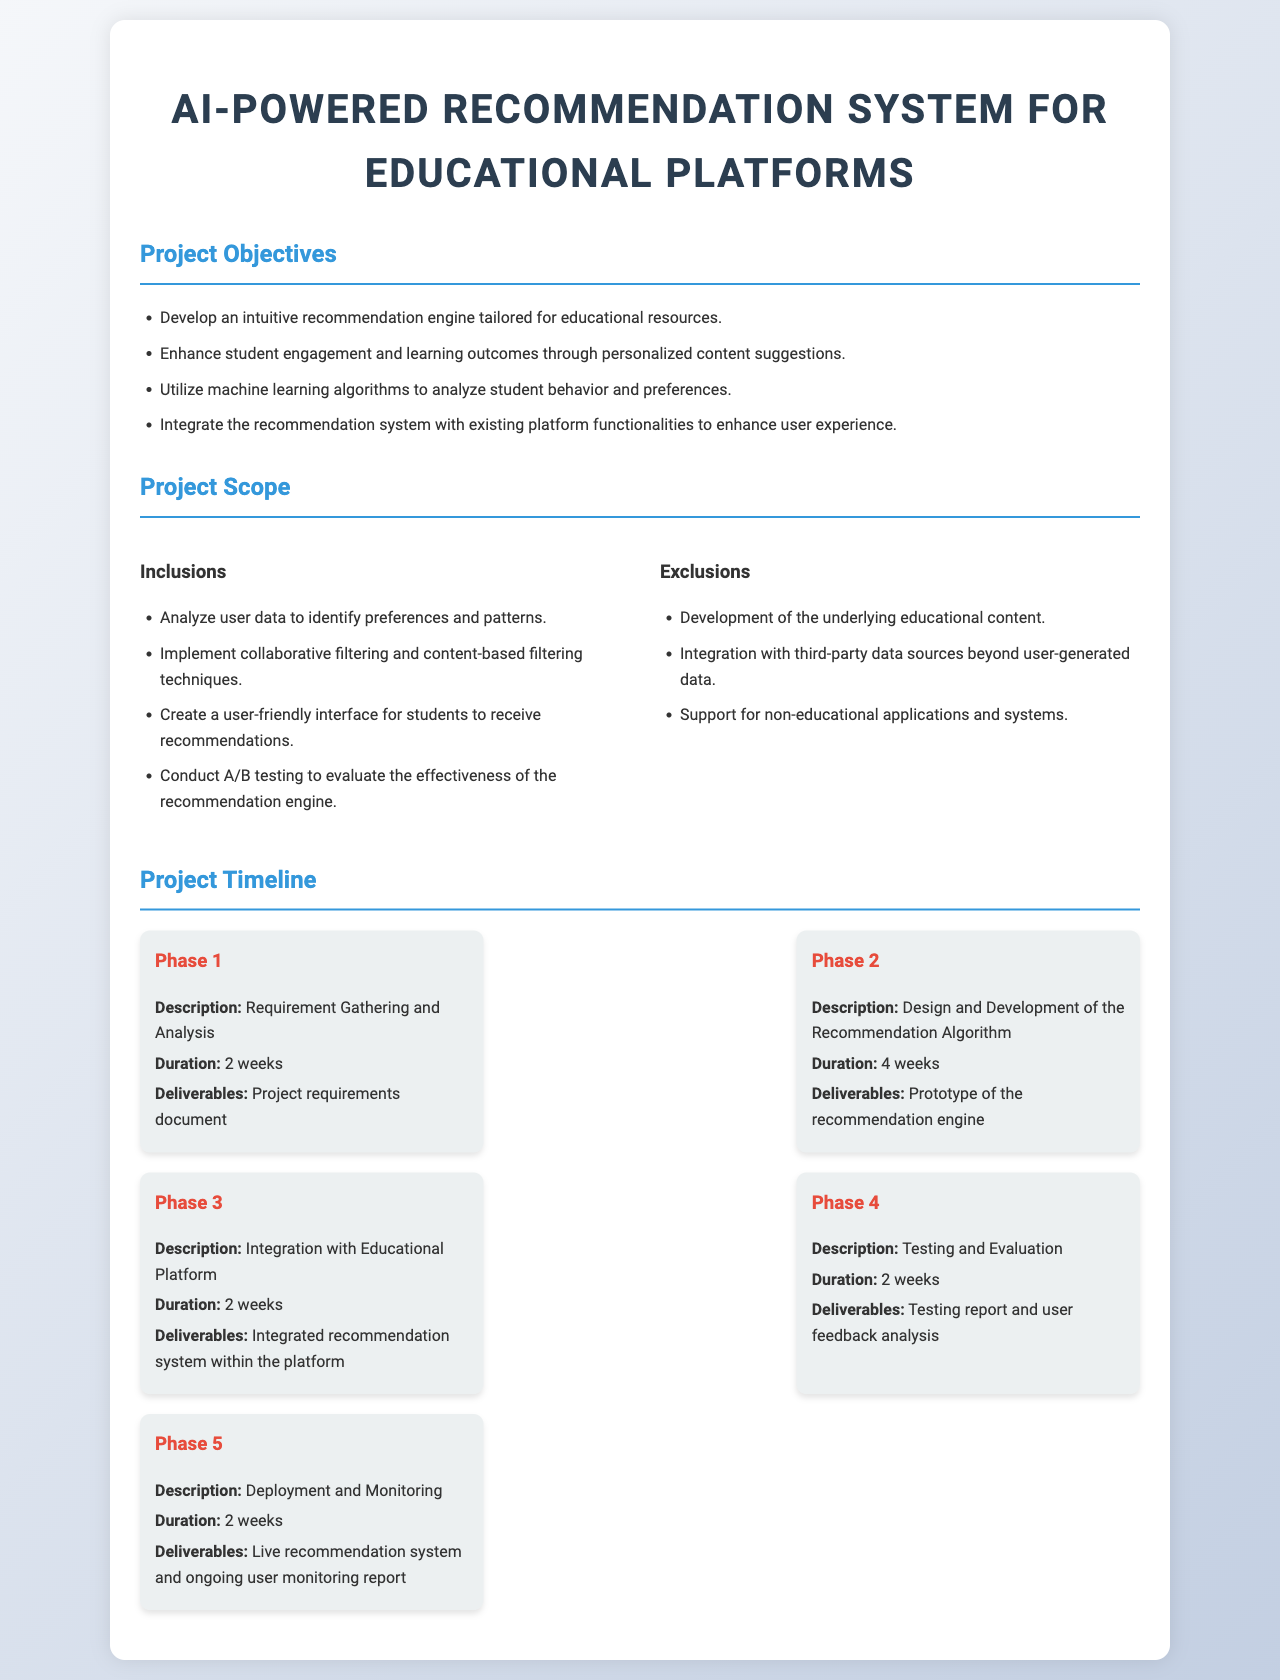what is the title of the project proposal? The title of the project proposal is stated in the heading of the document.
Answer: AI-Powered Recommendation System for Educational Platforms how many phases are outlined in the project timeline? The project timeline section includes a detailed breakdown of phases.
Answer: 5 what is the duration of Phase 1? The duration for Phase 1 is listed under the respective phase description.
Answer: 2 weeks what is the first deliverable of Phase 2? The deliverables for each phase are clearly outlined in the timeline.
Answer: Prototype of the recommendation engine which machine learning techniques will be implemented? The inclusions section specifies the techniques used in the development process.
Answer: Collaborative filtering and content-based filtering what is one objective of the project? The project objectives are listed in a bullet point format.
Answer: Develop an intuitive recommendation engine tailored for educational resources what is excluded from the project scope? The exclusions section highlights what is not included in the scope of the project.
Answer: Development of the underlying educational content what is the deliverable for Phase 5? Each phase has corresponding deliverables mentioned.
Answer: Live recommendation system and ongoing user monitoring report 